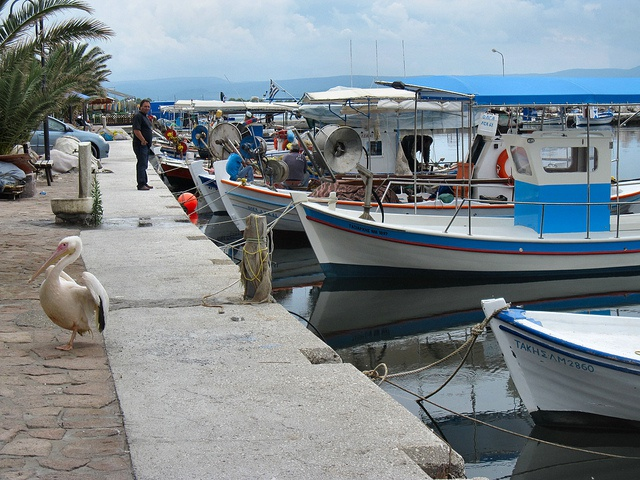Describe the objects in this image and their specific colors. I can see boat in black, gray, darkgray, and blue tones, boat in black, gray, white, and darkgray tones, boat in black, gray, darkgray, and lightgray tones, bird in black, gray, and darkgray tones, and boat in black, darkgray, lightgray, and gray tones in this image. 